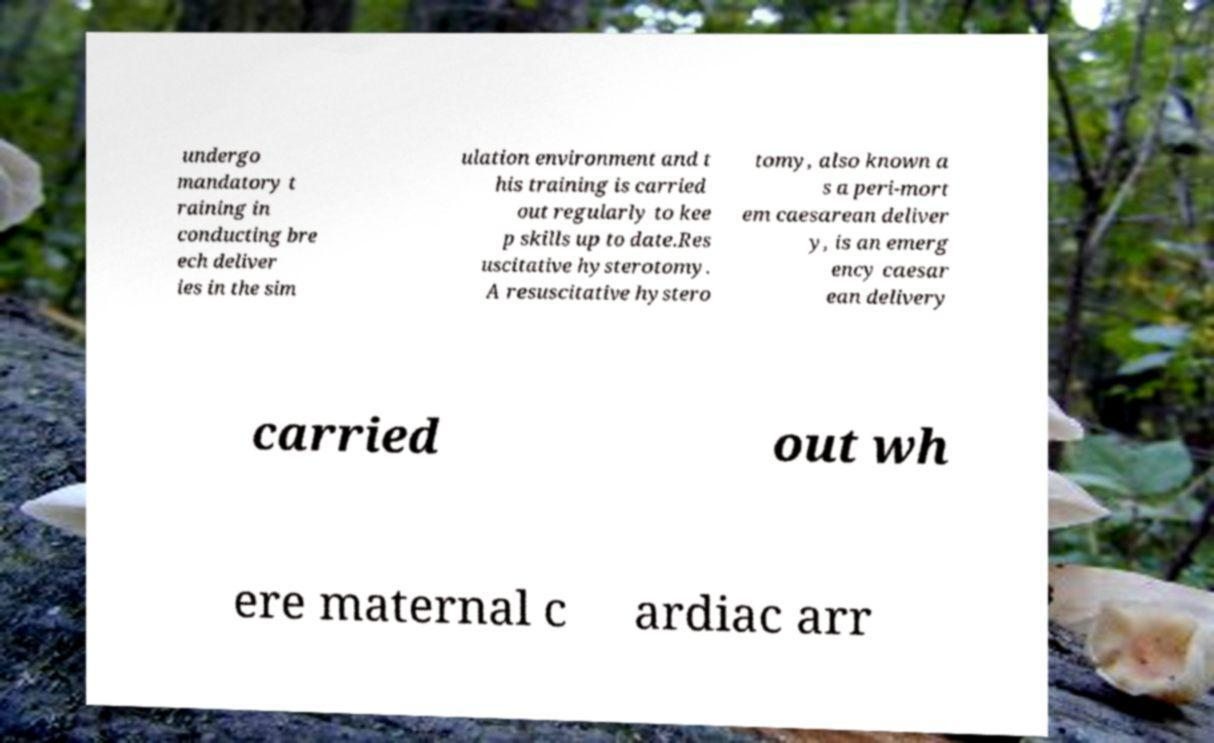Please read and relay the text visible in this image. What does it say? undergo mandatory t raining in conducting bre ech deliver ies in the sim ulation environment and t his training is carried out regularly to kee p skills up to date.Res uscitative hysterotomy. A resuscitative hystero tomy, also known a s a peri-mort em caesarean deliver y, is an emerg ency caesar ean delivery carried out wh ere maternal c ardiac arr 